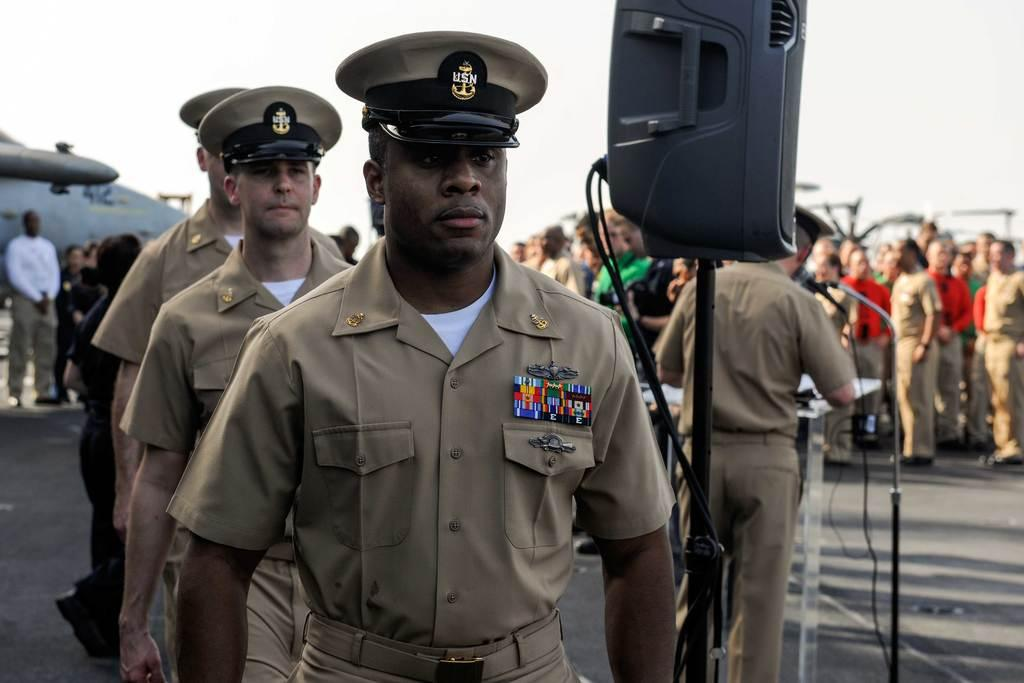What are the people in the image doing? The people are standing on the ground. What can be seen on the right side of the image? There is a podium, a microphone, and a speaker on the right side of the image. What is visible in the background of the image? There is an airplane and the sky visible in the background of the image. Where is the lake located in the image? There is no lake present in the image. What type of dolls can be seen playing near the airplane? There are no dolls present in the image. 